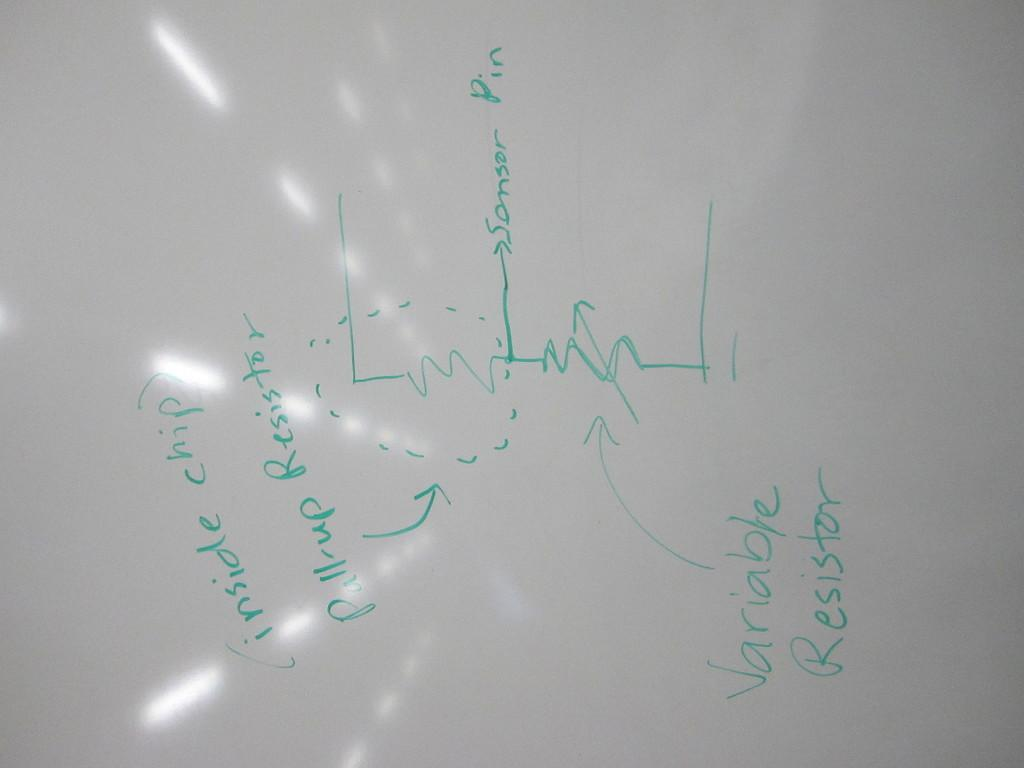<image>
Present a compact description of the photo's key features. A graph showing several variable including Variable Resistor. 